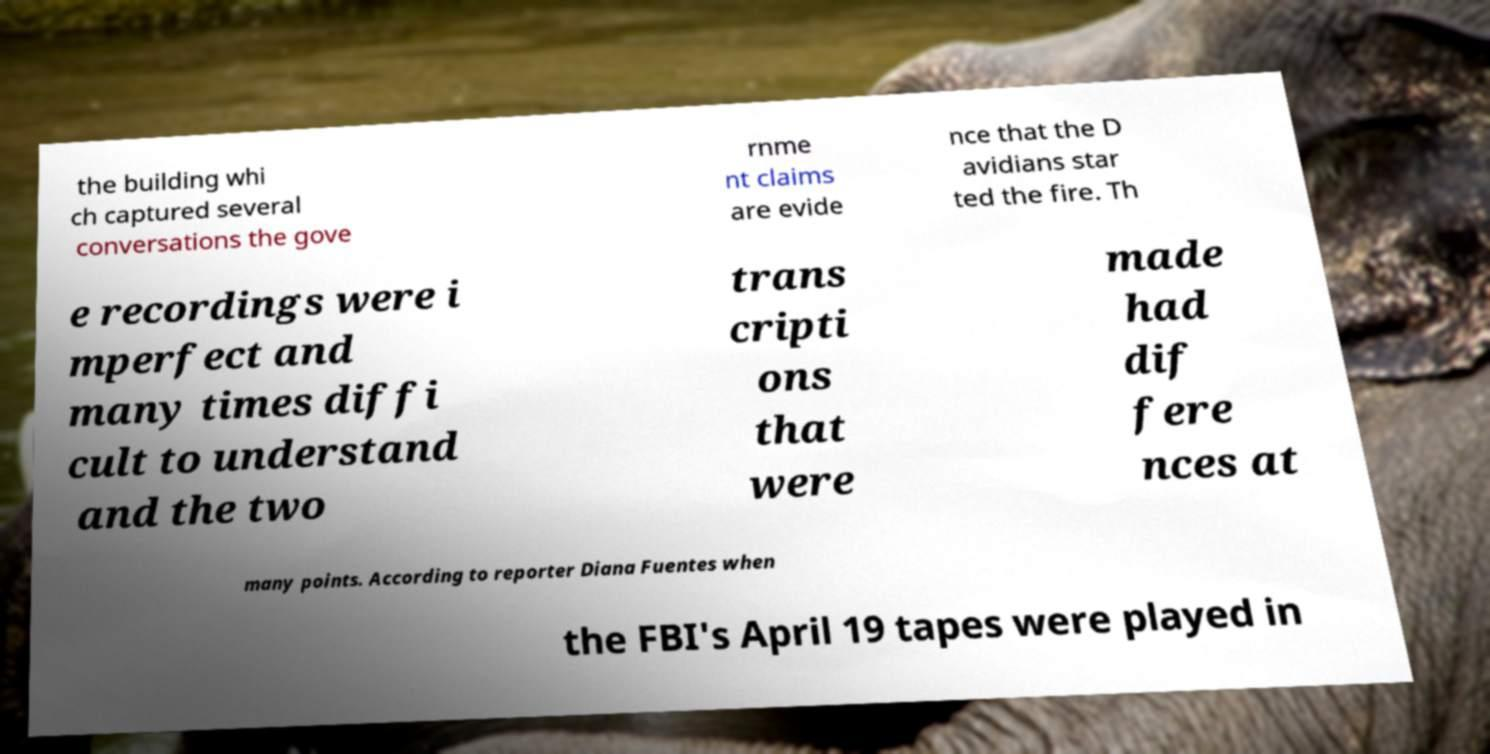I need the written content from this picture converted into text. Can you do that? the building whi ch captured several conversations the gove rnme nt claims are evide nce that the D avidians star ted the fire. Th e recordings were i mperfect and many times diffi cult to understand and the two trans cripti ons that were made had dif fere nces at many points. According to reporter Diana Fuentes when the FBI's April 19 tapes were played in 